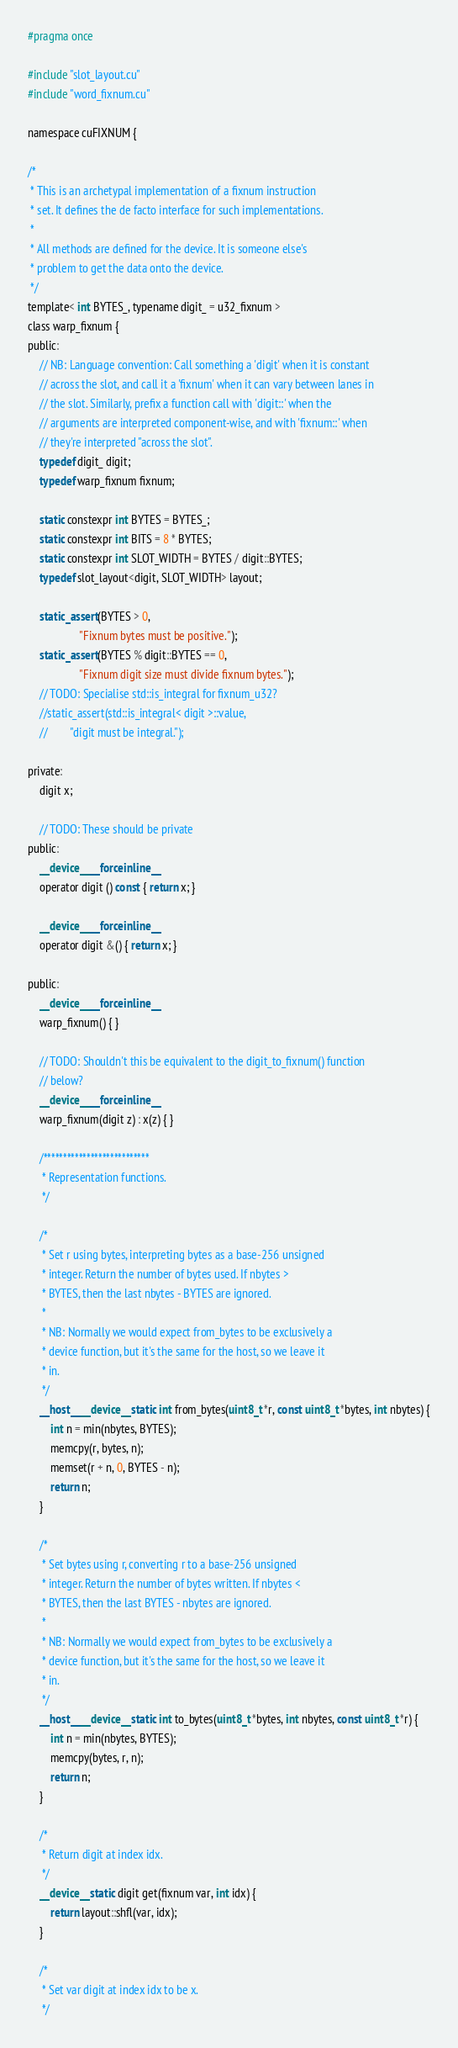Convert code to text. <code><loc_0><loc_0><loc_500><loc_500><_Cuda_>#pragma once

#include "slot_layout.cu"
#include "word_fixnum.cu"

namespace cuFIXNUM {

/*
 * This is an archetypal implementation of a fixnum instruction
 * set. It defines the de facto interface for such implementations.
 *
 * All methods are defined for the device. It is someone else's
 * problem to get the data onto the device.
 */
template< int BYTES_, typename digit_ = u32_fixnum >
class warp_fixnum {
public:
    // NB: Language convention: Call something a 'digit' when it is constant
    // across the slot, and call it a 'fixnum' when it can vary between lanes in
    // the slot. Similarly, prefix a function call with 'digit::' when the
    // arguments are interpreted component-wise, and with 'fixnum::' when
    // they're interpreted "across the slot".
    typedef digit_ digit;
    typedef warp_fixnum fixnum;

    static constexpr int BYTES = BYTES_;
    static constexpr int BITS = 8 * BYTES;
    static constexpr int SLOT_WIDTH = BYTES / digit::BYTES;
    typedef slot_layout<digit, SLOT_WIDTH> layout;

    static_assert(BYTES > 0,
                  "Fixnum bytes must be positive.");
    static_assert(BYTES % digit::BYTES == 0,
                  "Fixnum digit size must divide fixnum bytes.");
    // TODO: Specialise std::is_integral for fixnum_u32?
    //static_assert(std::is_integral< digit >::value,
    //        "digit must be integral.");

private:
    digit x;

    // TODO: These should be private
public:
    __device__ __forceinline__
    operator digit () const { return x; }

    __device__ __forceinline__
    operator digit &() { return x; }

public:
    __device__ __forceinline__
    warp_fixnum() { }

    // TODO: Shouldn't this be equivalent to the digit_to_fixnum() function
    // below?
    __device__ __forceinline__
    warp_fixnum(digit z) : x(z) { }

    /***************************
     * Representation functions.
     */

    /*
     * Set r using bytes, interpreting bytes as a base-256 unsigned
     * integer. Return the number of bytes used. If nbytes >
     * BYTES, then the last nbytes - BYTES are ignored.
     *
     * NB: Normally we would expect from_bytes to be exclusively a
     * device function, but it's the same for the host, so we leave it
     * in.
     */
    __host__ __device__ static int from_bytes(uint8_t *r, const uint8_t *bytes, int nbytes) {
        int n = min(nbytes, BYTES);
        memcpy(r, bytes, n);
        memset(r + n, 0, BYTES - n);
        return n;
    }

    /*
     * Set bytes using r, converting r to a base-256 unsigned
     * integer. Return the number of bytes written. If nbytes <
     * BYTES, then the last BYTES - nbytes are ignored.
     *
     * NB: Normally we would expect from_bytes to be exclusively a
     * device function, but it's the same for the host, so we leave it
     * in.
     */
    __host__ __device__ static int to_bytes(uint8_t *bytes, int nbytes, const uint8_t *r) {
        int n = min(nbytes, BYTES);
        memcpy(bytes, r, n);
        return n;
    }

    /*
     * Return digit at index idx.
     */
    __device__ static digit get(fixnum var, int idx) {
        return layout::shfl(var, idx);
    }

    /*
     * Set var digit at index idx to be x.
     */</code> 